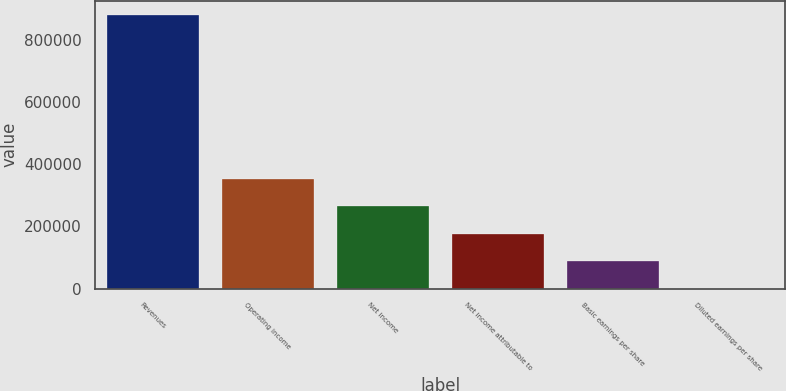Convert chart to OTSL. <chart><loc_0><loc_0><loc_500><loc_500><bar_chart><fcel>Revenues<fcel>Operating income<fcel>Net income<fcel>Net income attributable to<fcel>Basic earnings per share<fcel>Diluted earnings per share<nl><fcel>880555<fcel>352222<fcel>264167<fcel>176111<fcel>88055.9<fcel>0.47<nl></chart> 